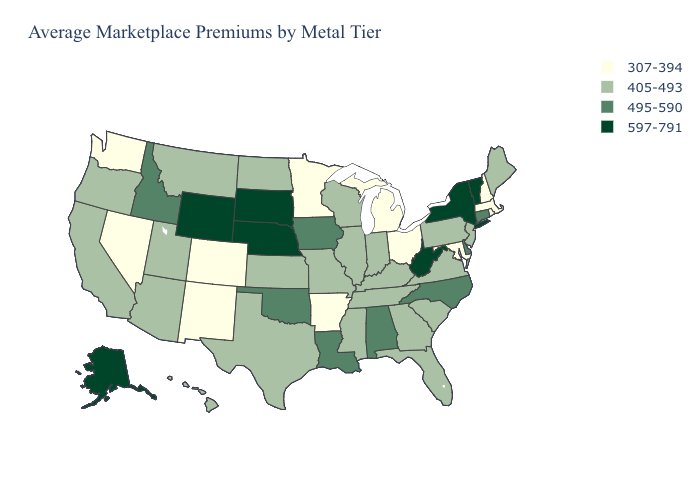What is the value of Georgia?
Keep it brief. 405-493. What is the value of Utah?
Be succinct. 405-493. Which states have the lowest value in the South?
Concise answer only. Arkansas, Maryland. What is the lowest value in the USA?
Concise answer only. 307-394. Name the states that have a value in the range 597-791?
Answer briefly. Alaska, Nebraska, New York, South Dakota, Vermont, West Virginia, Wyoming. What is the value of Michigan?
Be succinct. 307-394. Does Oklahoma have a higher value than Connecticut?
Short answer required. No. Does South Carolina have the same value as Wisconsin?
Be succinct. Yes. Name the states that have a value in the range 495-590?
Write a very short answer. Alabama, Connecticut, Delaware, Idaho, Iowa, Louisiana, North Carolina, Oklahoma. Which states have the lowest value in the USA?
Write a very short answer. Arkansas, Colorado, Maryland, Massachusetts, Michigan, Minnesota, Nevada, New Hampshire, New Mexico, Ohio, Rhode Island, Washington. What is the value of Missouri?
Keep it brief. 405-493. Which states have the lowest value in the West?
Give a very brief answer. Colorado, Nevada, New Mexico, Washington. Which states have the lowest value in the USA?
Short answer required. Arkansas, Colorado, Maryland, Massachusetts, Michigan, Minnesota, Nevada, New Hampshire, New Mexico, Ohio, Rhode Island, Washington. What is the value of New Mexico?
Quick response, please. 307-394. Which states hav the highest value in the Northeast?
Write a very short answer. New York, Vermont. 